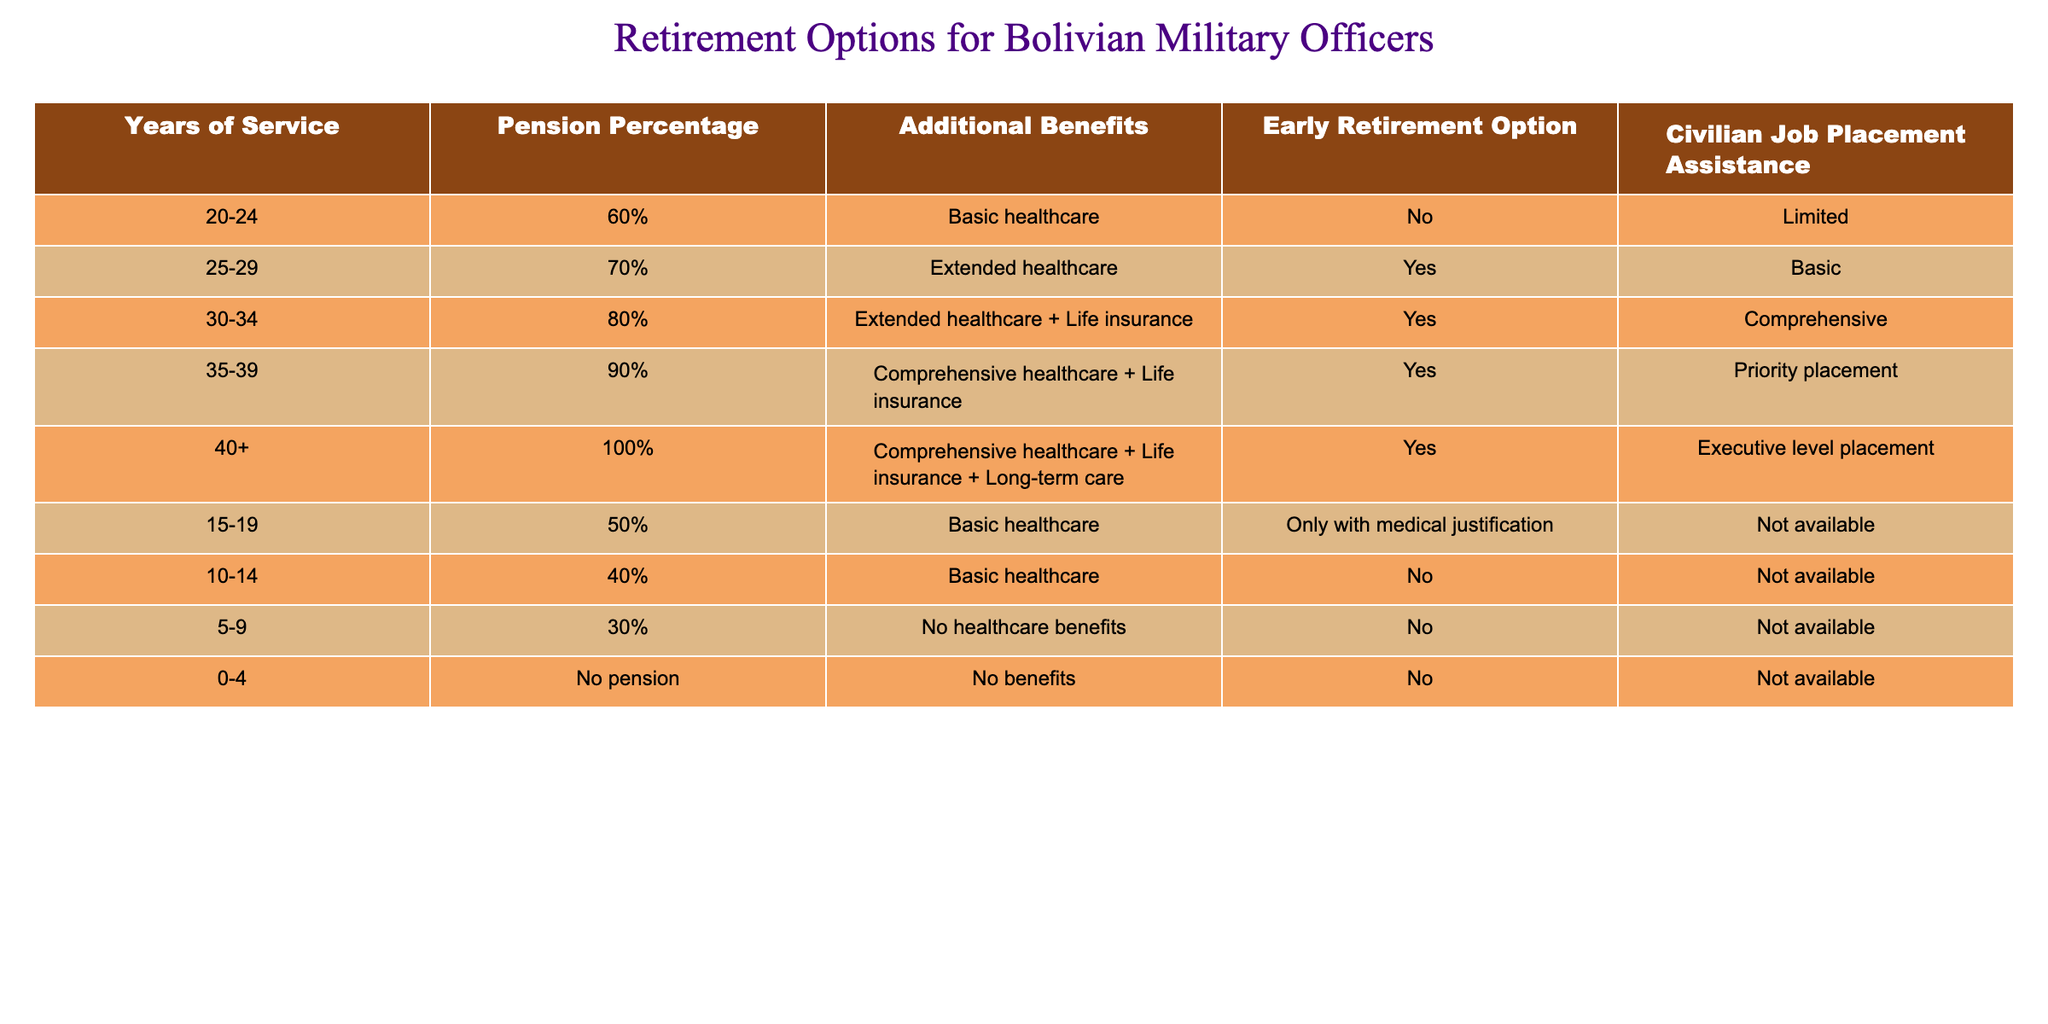What is the pension percentage for officers with 30-34 years of service? According to the table, officers with 30-34 years of service receive a pension of 80%.
Answer: 80% Do officers with 20-24 years of service have access to additional benefits? Yes, the table indicates that officers with 20-24 years of service receive basic healthcare as additional benefits.
Answer: Yes What is the earliest age at which officers can retire based on years of service? Officers with 15-19 years of service may retire early but only with medical justification, making this the earliest option for early retirement without a standard condition.
Answer: 15-19 years How many benefits are provided to officers with 40+ years of service? Officers with 40+ years of service receive three benefits: comprehensive healthcare, life insurance, and long-term care, adding up to a total of three benefits.
Answer: 3 benefits What is the pension percentage difference between officers with 15-19 years of service and those with 25-29 years? Officers with 15-19 years of service receive 50%, while those with 25-29 years of service receive 70%. The difference is 70% - 50% = 20%.
Answer: 20% Are any officers in the 0-4 years of service category eligible for civilian job placement assistance? No, as shown in the table, officers with 0-4 years of service do not receive any benefits, including civilian job placement assistance.
Answer: No Is the healthcare option for officers retiring with 35-39 years of service better than for those retiring with 20-24 years? Yes, officers with 35-39 years of service receive comprehensive healthcare plus life insurance, which is more extensive than the basic healthcare provided to those with 20-24 years of service.
Answer: Yes What percentage of pension do officers with 5-9 years of service receive? Officers in the 5-9 years category receive a pension of 30%.
Answer: 30% How many categories of service years provide access to extended healthcare? There are two categories: 25-29 years and 30-34 years, both of which include extended healthcare as part of their benefits.
Answer: 2 categories 